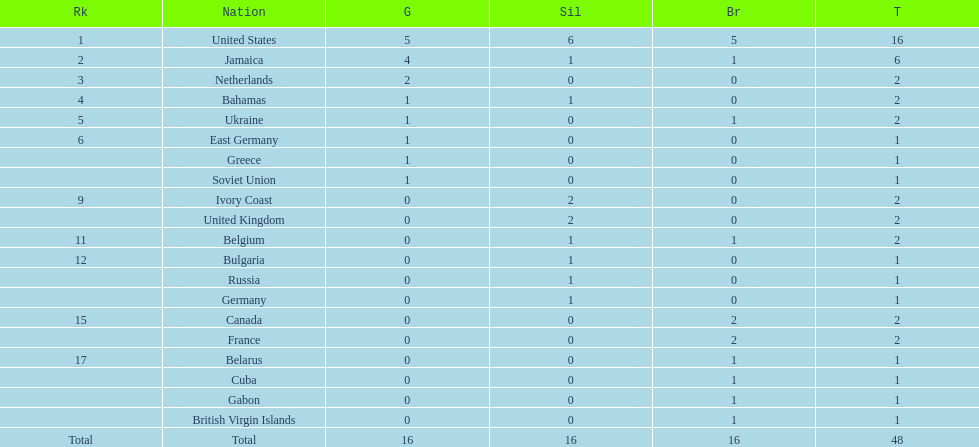What is the total number of gold medals won by jamaica? 4. 